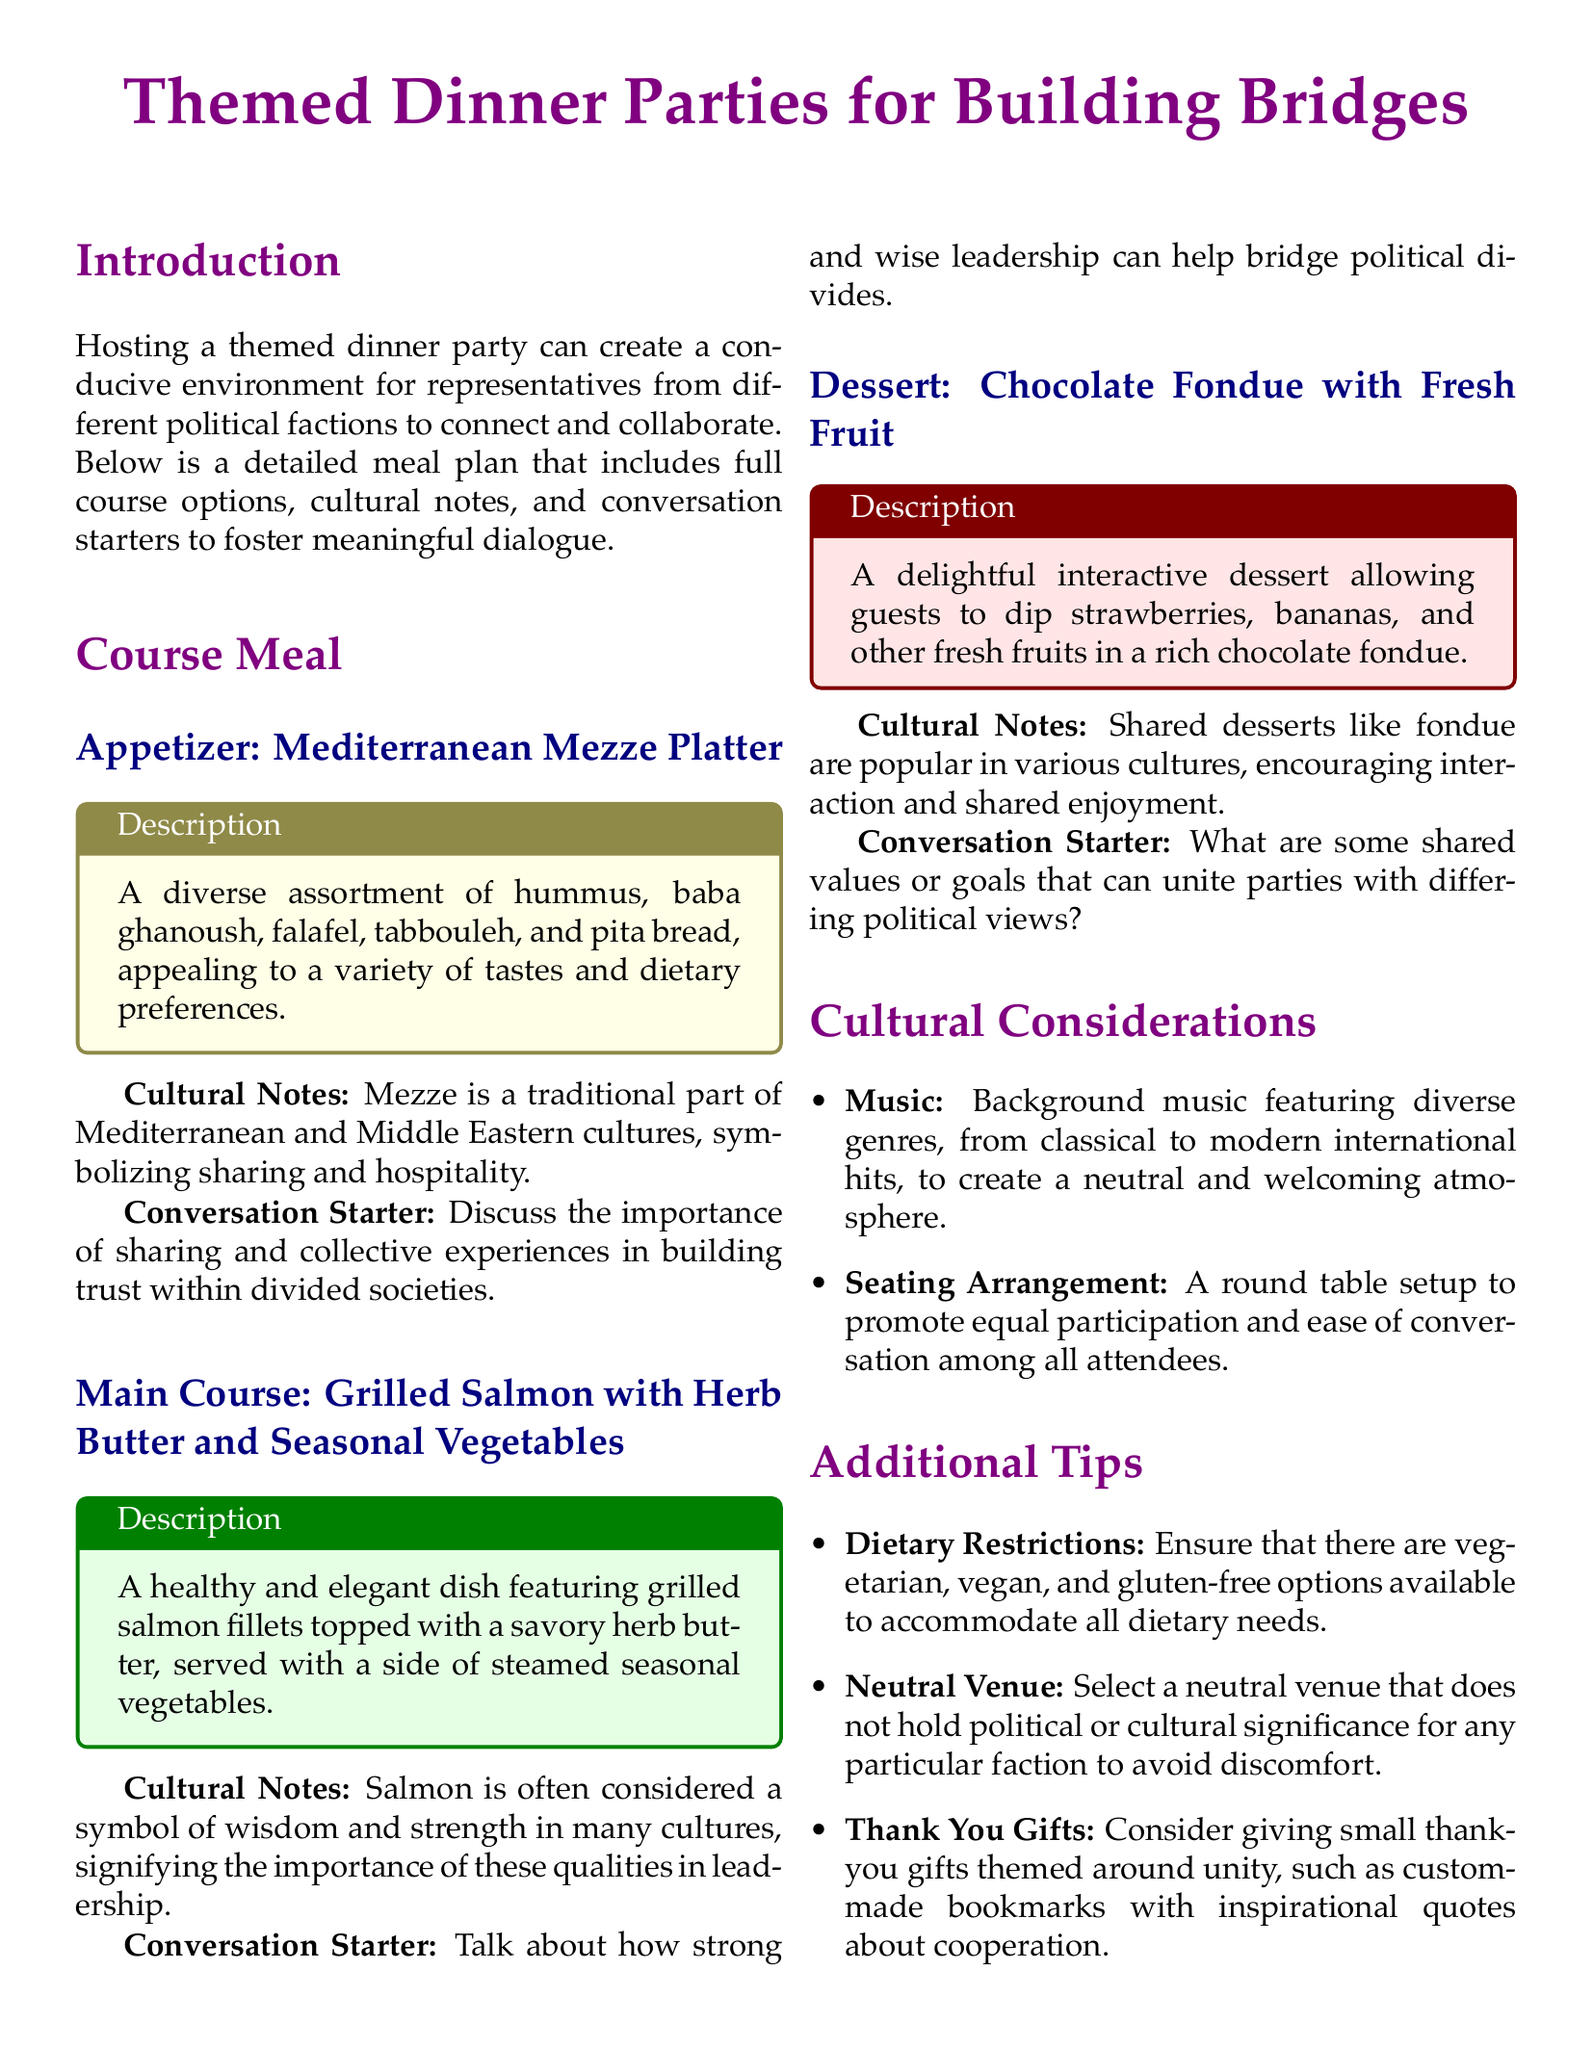what is served as the appetizer? The appetizer is a diverse assortment of hummus, baba ghanoush, falafel, tabbouleh, and pita bread.
Answer: Mediterranean Mezze Platter what is the main course of the meal plan? The main course features grilled salmon fillets topped with herb butter and served with seasonal vegetables.
Answer: Grilled Salmon with Herb Butter and Seasonal Vegetables what type of dessert is included in the meal plan? The dessert allows guests to dip fruits in a rich chocolate fondue.
Answer: Chocolate Fondue with Fresh Fruit what cultural significance does salmon hold in the document? Salmon is often considered a symbol of wisdom and strength in many cultures.
Answer: Wisdom and strength how many conversation starters are provided in the document? There are three conversation starters, one for each course of the meal.
Answer: Three what kind of music is suggested for the dinner party? Background music featuring diverse genres such as classical to modern international hits is suggested.
Answer: Diverse genres what is a key dietary consideration mentioned in the plan? The plan emphasizes the importance of accommodating all dietary needs, including vegetarian, vegan, and gluten-free options.
Answer: Dietary restrictions what seating arrangement is recommended for promoting conversation? A round table setup is recommended to promote equal participation and ease of conversation.
Answer: Round table setup 